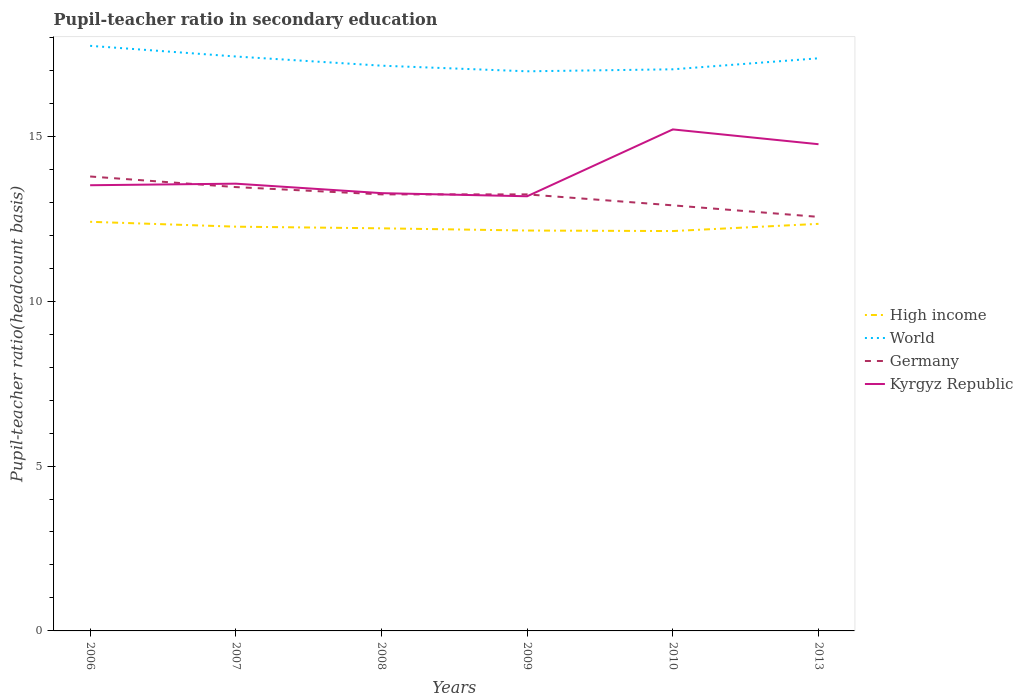Across all years, what is the maximum pupil-teacher ratio in secondary education in High income?
Your response must be concise. 12.13. In which year was the pupil-teacher ratio in secondary education in Germany maximum?
Provide a short and direct response. 2013. What is the total pupil-teacher ratio in secondary education in High income in the graph?
Give a very brief answer. 0.15. What is the difference between the highest and the second highest pupil-teacher ratio in secondary education in High income?
Offer a very short reply. 0.28. How many years are there in the graph?
Provide a succinct answer. 6. What is the difference between two consecutive major ticks on the Y-axis?
Ensure brevity in your answer.  5. Are the values on the major ticks of Y-axis written in scientific E-notation?
Keep it short and to the point. No. Where does the legend appear in the graph?
Provide a short and direct response. Center right. How are the legend labels stacked?
Provide a short and direct response. Vertical. What is the title of the graph?
Your response must be concise. Pupil-teacher ratio in secondary education. Does "Saudi Arabia" appear as one of the legend labels in the graph?
Provide a short and direct response. No. What is the label or title of the Y-axis?
Offer a terse response. Pupil-teacher ratio(headcount basis). What is the Pupil-teacher ratio(headcount basis) in High income in 2006?
Keep it short and to the point. 12.41. What is the Pupil-teacher ratio(headcount basis) of World in 2006?
Provide a succinct answer. 17.74. What is the Pupil-teacher ratio(headcount basis) in Germany in 2006?
Provide a short and direct response. 13.78. What is the Pupil-teacher ratio(headcount basis) of Kyrgyz Republic in 2006?
Provide a succinct answer. 13.52. What is the Pupil-teacher ratio(headcount basis) of High income in 2007?
Your answer should be very brief. 12.26. What is the Pupil-teacher ratio(headcount basis) of World in 2007?
Provide a short and direct response. 17.42. What is the Pupil-teacher ratio(headcount basis) of Germany in 2007?
Give a very brief answer. 13.46. What is the Pupil-teacher ratio(headcount basis) in Kyrgyz Republic in 2007?
Provide a short and direct response. 13.56. What is the Pupil-teacher ratio(headcount basis) in High income in 2008?
Offer a very short reply. 12.21. What is the Pupil-teacher ratio(headcount basis) of World in 2008?
Your response must be concise. 17.14. What is the Pupil-teacher ratio(headcount basis) of Germany in 2008?
Provide a short and direct response. 13.24. What is the Pupil-teacher ratio(headcount basis) in Kyrgyz Republic in 2008?
Keep it short and to the point. 13.28. What is the Pupil-teacher ratio(headcount basis) in High income in 2009?
Offer a terse response. 12.14. What is the Pupil-teacher ratio(headcount basis) in World in 2009?
Keep it short and to the point. 16.97. What is the Pupil-teacher ratio(headcount basis) in Germany in 2009?
Make the answer very short. 13.24. What is the Pupil-teacher ratio(headcount basis) of Kyrgyz Republic in 2009?
Your response must be concise. 13.18. What is the Pupil-teacher ratio(headcount basis) in High income in 2010?
Keep it short and to the point. 12.13. What is the Pupil-teacher ratio(headcount basis) in World in 2010?
Ensure brevity in your answer.  17.03. What is the Pupil-teacher ratio(headcount basis) of Germany in 2010?
Keep it short and to the point. 12.91. What is the Pupil-teacher ratio(headcount basis) in Kyrgyz Republic in 2010?
Offer a terse response. 15.21. What is the Pupil-teacher ratio(headcount basis) in High income in 2013?
Make the answer very short. 12.34. What is the Pupil-teacher ratio(headcount basis) of World in 2013?
Make the answer very short. 17.37. What is the Pupil-teacher ratio(headcount basis) of Germany in 2013?
Give a very brief answer. 12.56. What is the Pupil-teacher ratio(headcount basis) in Kyrgyz Republic in 2013?
Keep it short and to the point. 14.76. Across all years, what is the maximum Pupil-teacher ratio(headcount basis) in High income?
Your answer should be very brief. 12.41. Across all years, what is the maximum Pupil-teacher ratio(headcount basis) in World?
Provide a succinct answer. 17.74. Across all years, what is the maximum Pupil-teacher ratio(headcount basis) of Germany?
Your answer should be very brief. 13.78. Across all years, what is the maximum Pupil-teacher ratio(headcount basis) of Kyrgyz Republic?
Your response must be concise. 15.21. Across all years, what is the minimum Pupil-teacher ratio(headcount basis) in High income?
Give a very brief answer. 12.13. Across all years, what is the minimum Pupil-teacher ratio(headcount basis) in World?
Your answer should be very brief. 16.97. Across all years, what is the minimum Pupil-teacher ratio(headcount basis) in Germany?
Offer a terse response. 12.56. Across all years, what is the minimum Pupil-teacher ratio(headcount basis) of Kyrgyz Republic?
Your response must be concise. 13.18. What is the total Pupil-teacher ratio(headcount basis) in High income in the graph?
Your response must be concise. 73.49. What is the total Pupil-teacher ratio(headcount basis) of World in the graph?
Your answer should be compact. 103.67. What is the total Pupil-teacher ratio(headcount basis) in Germany in the graph?
Your response must be concise. 79.18. What is the total Pupil-teacher ratio(headcount basis) in Kyrgyz Republic in the graph?
Your answer should be compact. 83.51. What is the difference between the Pupil-teacher ratio(headcount basis) in High income in 2006 and that in 2007?
Provide a short and direct response. 0.15. What is the difference between the Pupil-teacher ratio(headcount basis) of World in 2006 and that in 2007?
Your answer should be compact. 0.32. What is the difference between the Pupil-teacher ratio(headcount basis) of Germany in 2006 and that in 2007?
Offer a terse response. 0.32. What is the difference between the Pupil-teacher ratio(headcount basis) in Kyrgyz Republic in 2006 and that in 2007?
Make the answer very short. -0.05. What is the difference between the Pupil-teacher ratio(headcount basis) in High income in 2006 and that in 2008?
Provide a succinct answer. 0.2. What is the difference between the Pupil-teacher ratio(headcount basis) in World in 2006 and that in 2008?
Give a very brief answer. 0.6. What is the difference between the Pupil-teacher ratio(headcount basis) in Germany in 2006 and that in 2008?
Your answer should be compact. 0.54. What is the difference between the Pupil-teacher ratio(headcount basis) of Kyrgyz Republic in 2006 and that in 2008?
Your answer should be very brief. 0.24. What is the difference between the Pupil-teacher ratio(headcount basis) of High income in 2006 and that in 2009?
Give a very brief answer. 0.27. What is the difference between the Pupil-teacher ratio(headcount basis) of World in 2006 and that in 2009?
Keep it short and to the point. 0.77. What is the difference between the Pupil-teacher ratio(headcount basis) in Germany in 2006 and that in 2009?
Offer a very short reply. 0.54. What is the difference between the Pupil-teacher ratio(headcount basis) of Kyrgyz Republic in 2006 and that in 2009?
Offer a very short reply. 0.33. What is the difference between the Pupil-teacher ratio(headcount basis) in High income in 2006 and that in 2010?
Ensure brevity in your answer.  0.28. What is the difference between the Pupil-teacher ratio(headcount basis) in World in 2006 and that in 2010?
Provide a succinct answer. 0.71. What is the difference between the Pupil-teacher ratio(headcount basis) of Germany in 2006 and that in 2010?
Offer a very short reply. 0.88. What is the difference between the Pupil-teacher ratio(headcount basis) in Kyrgyz Republic in 2006 and that in 2010?
Offer a terse response. -1.69. What is the difference between the Pupil-teacher ratio(headcount basis) in High income in 2006 and that in 2013?
Ensure brevity in your answer.  0.06. What is the difference between the Pupil-teacher ratio(headcount basis) in World in 2006 and that in 2013?
Provide a short and direct response. 0.38. What is the difference between the Pupil-teacher ratio(headcount basis) of Germany in 2006 and that in 2013?
Offer a terse response. 1.22. What is the difference between the Pupil-teacher ratio(headcount basis) in Kyrgyz Republic in 2006 and that in 2013?
Your answer should be compact. -1.24. What is the difference between the Pupil-teacher ratio(headcount basis) in High income in 2007 and that in 2008?
Provide a succinct answer. 0.05. What is the difference between the Pupil-teacher ratio(headcount basis) in World in 2007 and that in 2008?
Offer a terse response. 0.28. What is the difference between the Pupil-teacher ratio(headcount basis) in Germany in 2007 and that in 2008?
Provide a short and direct response. 0.22. What is the difference between the Pupil-teacher ratio(headcount basis) of Kyrgyz Republic in 2007 and that in 2008?
Provide a short and direct response. 0.29. What is the difference between the Pupil-teacher ratio(headcount basis) of High income in 2007 and that in 2009?
Keep it short and to the point. 0.12. What is the difference between the Pupil-teacher ratio(headcount basis) in World in 2007 and that in 2009?
Ensure brevity in your answer.  0.45. What is the difference between the Pupil-teacher ratio(headcount basis) in Germany in 2007 and that in 2009?
Provide a succinct answer. 0.22. What is the difference between the Pupil-teacher ratio(headcount basis) in Kyrgyz Republic in 2007 and that in 2009?
Provide a succinct answer. 0.38. What is the difference between the Pupil-teacher ratio(headcount basis) in High income in 2007 and that in 2010?
Your answer should be very brief. 0.13. What is the difference between the Pupil-teacher ratio(headcount basis) in World in 2007 and that in 2010?
Offer a terse response. 0.39. What is the difference between the Pupil-teacher ratio(headcount basis) in Germany in 2007 and that in 2010?
Your answer should be compact. 0.55. What is the difference between the Pupil-teacher ratio(headcount basis) of Kyrgyz Republic in 2007 and that in 2010?
Provide a short and direct response. -1.65. What is the difference between the Pupil-teacher ratio(headcount basis) in High income in 2007 and that in 2013?
Keep it short and to the point. -0.09. What is the difference between the Pupil-teacher ratio(headcount basis) in World in 2007 and that in 2013?
Ensure brevity in your answer.  0.05. What is the difference between the Pupil-teacher ratio(headcount basis) of Germany in 2007 and that in 2013?
Make the answer very short. 0.9. What is the difference between the Pupil-teacher ratio(headcount basis) in Kyrgyz Republic in 2007 and that in 2013?
Ensure brevity in your answer.  -1.2. What is the difference between the Pupil-teacher ratio(headcount basis) of High income in 2008 and that in 2009?
Keep it short and to the point. 0.07. What is the difference between the Pupil-teacher ratio(headcount basis) of World in 2008 and that in 2009?
Your response must be concise. 0.17. What is the difference between the Pupil-teacher ratio(headcount basis) in Kyrgyz Republic in 2008 and that in 2009?
Offer a very short reply. 0.1. What is the difference between the Pupil-teacher ratio(headcount basis) of High income in 2008 and that in 2010?
Make the answer very short. 0.08. What is the difference between the Pupil-teacher ratio(headcount basis) in World in 2008 and that in 2010?
Your answer should be very brief. 0.11. What is the difference between the Pupil-teacher ratio(headcount basis) in Germany in 2008 and that in 2010?
Offer a terse response. 0.33. What is the difference between the Pupil-teacher ratio(headcount basis) in Kyrgyz Republic in 2008 and that in 2010?
Offer a terse response. -1.93. What is the difference between the Pupil-teacher ratio(headcount basis) of High income in 2008 and that in 2013?
Provide a short and direct response. -0.14. What is the difference between the Pupil-teacher ratio(headcount basis) of World in 2008 and that in 2013?
Your response must be concise. -0.22. What is the difference between the Pupil-teacher ratio(headcount basis) in Germany in 2008 and that in 2013?
Offer a terse response. 0.68. What is the difference between the Pupil-teacher ratio(headcount basis) of Kyrgyz Republic in 2008 and that in 2013?
Your response must be concise. -1.48. What is the difference between the Pupil-teacher ratio(headcount basis) of High income in 2009 and that in 2010?
Provide a succinct answer. 0.02. What is the difference between the Pupil-teacher ratio(headcount basis) in World in 2009 and that in 2010?
Give a very brief answer. -0.06. What is the difference between the Pupil-teacher ratio(headcount basis) in Germany in 2009 and that in 2010?
Offer a very short reply. 0.33. What is the difference between the Pupil-teacher ratio(headcount basis) in Kyrgyz Republic in 2009 and that in 2010?
Ensure brevity in your answer.  -2.03. What is the difference between the Pupil-teacher ratio(headcount basis) of High income in 2009 and that in 2013?
Give a very brief answer. -0.2. What is the difference between the Pupil-teacher ratio(headcount basis) of World in 2009 and that in 2013?
Keep it short and to the point. -0.39. What is the difference between the Pupil-teacher ratio(headcount basis) of Germany in 2009 and that in 2013?
Your answer should be very brief. 0.68. What is the difference between the Pupil-teacher ratio(headcount basis) of Kyrgyz Republic in 2009 and that in 2013?
Offer a terse response. -1.58. What is the difference between the Pupil-teacher ratio(headcount basis) of High income in 2010 and that in 2013?
Provide a short and direct response. -0.22. What is the difference between the Pupil-teacher ratio(headcount basis) of World in 2010 and that in 2013?
Ensure brevity in your answer.  -0.33. What is the difference between the Pupil-teacher ratio(headcount basis) in Germany in 2010 and that in 2013?
Your response must be concise. 0.35. What is the difference between the Pupil-teacher ratio(headcount basis) of Kyrgyz Republic in 2010 and that in 2013?
Ensure brevity in your answer.  0.45. What is the difference between the Pupil-teacher ratio(headcount basis) of High income in 2006 and the Pupil-teacher ratio(headcount basis) of World in 2007?
Make the answer very short. -5.01. What is the difference between the Pupil-teacher ratio(headcount basis) of High income in 2006 and the Pupil-teacher ratio(headcount basis) of Germany in 2007?
Ensure brevity in your answer.  -1.05. What is the difference between the Pupil-teacher ratio(headcount basis) of High income in 2006 and the Pupil-teacher ratio(headcount basis) of Kyrgyz Republic in 2007?
Keep it short and to the point. -1.16. What is the difference between the Pupil-teacher ratio(headcount basis) in World in 2006 and the Pupil-teacher ratio(headcount basis) in Germany in 2007?
Ensure brevity in your answer.  4.28. What is the difference between the Pupil-teacher ratio(headcount basis) of World in 2006 and the Pupil-teacher ratio(headcount basis) of Kyrgyz Republic in 2007?
Your answer should be compact. 4.18. What is the difference between the Pupil-teacher ratio(headcount basis) of Germany in 2006 and the Pupil-teacher ratio(headcount basis) of Kyrgyz Republic in 2007?
Give a very brief answer. 0.22. What is the difference between the Pupil-teacher ratio(headcount basis) in High income in 2006 and the Pupil-teacher ratio(headcount basis) in World in 2008?
Offer a very short reply. -4.73. What is the difference between the Pupil-teacher ratio(headcount basis) of High income in 2006 and the Pupil-teacher ratio(headcount basis) of Germany in 2008?
Your answer should be very brief. -0.83. What is the difference between the Pupil-teacher ratio(headcount basis) of High income in 2006 and the Pupil-teacher ratio(headcount basis) of Kyrgyz Republic in 2008?
Provide a succinct answer. -0.87. What is the difference between the Pupil-teacher ratio(headcount basis) of World in 2006 and the Pupil-teacher ratio(headcount basis) of Germany in 2008?
Make the answer very short. 4.5. What is the difference between the Pupil-teacher ratio(headcount basis) of World in 2006 and the Pupil-teacher ratio(headcount basis) of Kyrgyz Republic in 2008?
Your answer should be very brief. 4.47. What is the difference between the Pupil-teacher ratio(headcount basis) in Germany in 2006 and the Pupil-teacher ratio(headcount basis) in Kyrgyz Republic in 2008?
Your response must be concise. 0.5. What is the difference between the Pupil-teacher ratio(headcount basis) of High income in 2006 and the Pupil-teacher ratio(headcount basis) of World in 2009?
Keep it short and to the point. -4.56. What is the difference between the Pupil-teacher ratio(headcount basis) of High income in 2006 and the Pupil-teacher ratio(headcount basis) of Germany in 2009?
Provide a succinct answer. -0.83. What is the difference between the Pupil-teacher ratio(headcount basis) of High income in 2006 and the Pupil-teacher ratio(headcount basis) of Kyrgyz Republic in 2009?
Offer a terse response. -0.77. What is the difference between the Pupil-teacher ratio(headcount basis) of World in 2006 and the Pupil-teacher ratio(headcount basis) of Germany in 2009?
Offer a terse response. 4.5. What is the difference between the Pupil-teacher ratio(headcount basis) in World in 2006 and the Pupil-teacher ratio(headcount basis) in Kyrgyz Republic in 2009?
Provide a succinct answer. 4.56. What is the difference between the Pupil-teacher ratio(headcount basis) of Germany in 2006 and the Pupil-teacher ratio(headcount basis) of Kyrgyz Republic in 2009?
Make the answer very short. 0.6. What is the difference between the Pupil-teacher ratio(headcount basis) of High income in 2006 and the Pupil-teacher ratio(headcount basis) of World in 2010?
Provide a short and direct response. -4.62. What is the difference between the Pupil-teacher ratio(headcount basis) of High income in 2006 and the Pupil-teacher ratio(headcount basis) of Germany in 2010?
Offer a terse response. -0.5. What is the difference between the Pupil-teacher ratio(headcount basis) of High income in 2006 and the Pupil-teacher ratio(headcount basis) of Kyrgyz Republic in 2010?
Make the answer very short. -2.8. What is the difference between the Pupil-teacher ratio(headcount basis) of World in 2006 and the Pupil-teacher ratio(headcount basis) of Germany in 2010?
Offer a very short reply. 4.84. What is the difference between the Pupil-teacher ratio(headcount basis) in World in 2006 and the Pupil-teacher ratio(headcount basis) in Kyrgyz Republic in 2010?
Ensure brevity in your answer.  2.53. What is the difference between the Pupil-teacher ratio(headcount basis) of Germany in 2006 and the Pupil-teacher ratio(headcount basis) of Kyrgyz Republic in 2010?
Provide a succinct answer. -1.43. What is the difference between the Pupil-teacher ratio(headcount basis) of High income in 2006 and the Pupil-teacher ratio(headcount basis) of World in 2013?
Make the answer very short. -4.96. What is the difference between the Pupil-teacher ratio(headcount basis) of High income in 2006 and the Pupil-teacher ratio(headcount basis) of Germany in 2013?
Offer a very short reply. -0.15. What is the difference between the Pupil-teacher ratio(headcount basis) in High income in 2006 and the Pupil-teacher ratio(headcount basis) in Kyrgyz Republic in 2013?
Give a very brief answer. -2.35. What is the difference between the Pupil-teacher ratio(headcount basis) in World in 2006 and the Pupil-teacher ratio(headcount basis) in Germany in 2013?
Provide a succinct answer. 5.19. What is the difference between the Pupil-teacher ratio(headcount basis) in World in 2006 and the Pupil-teacher ratio(headcount basis) in Kyrgyz Republic in 2013?
Provide a succinct answer. 2.98. What is the difference between the Pupil-teacher ratio(headcount basis) in Germany in 2006 and the Pupil-teacher ratio(headcount basis) in Kyrgyz Republic in 2013?
Give a very brief answer. -0.98. What is the difference between the Pupil-teacher ratio(headcount basis) in High income in 2007 and the Pupil-teacher ratio(headcount basis) in World in 2008?
Ensure brevity in your answer.  -4.88. What is the difference between the Pupil-teacher ratio(headcount basis) in High income in 2007 and the Pupil-teacher ratio(headcount basis) in Germany in 2008?
Keep it short and to the point. -0.98. What is the difference between the Pupil-teacher ratio(headcount basis) in High income in 2007 and the Pupil-teacher ratio(headcount basis) in Kyrgyz Republic in 2008?
Offer a terse response. -1.02. What is the difference between the Pupil-teacher ratio(headcount basis) of World in 2007 and the Pupil-teacher ratio(headcount basis) of Germany in 2008?
Provide a succinct answer. 4.18. What is the difference between the Pupil-teacher ratio(headcount basis) of World in 2007 and the Pupil-teacher ratio(headcount basis) of Kyrgyz Republic in 2008?
Keep it short and to the point. 4.14. What is the difference between the Pupil-teacher ratio(headcount basis) of Germany in 2007 and the Pupil-teacher ratio(headcount basis) of Kyrgyz Republic in 2008?
Keep it short and to the point. 0.18. What is the difference between the Pupil-teacher ratio(headcount basis) in High income in 2007 and the Pupil-teacher ratio(headcount basis) in World in 2009?
Provide a short and direct response. -4.71. What is the difference between the Pupil-teacher ratio(headcount basis) in High income in 2007 and the Pupil-teacher ratio(headcount basis) in Germany in 2009?
Provide a short and direct response. -0.98. What is the difference between the Pupil-teacher ratio(headcount basis) in High income in 2007 and the Pupil-teacher ratio(headcount basis) in Kyrgyz Republic in 2009?
Ensure brevity in your answer.  -0.92. What is the difference between the Pupil-teacher ratio(headcount basis) in World in 2007 and the Pupil-teacher ratio(headcount basis) in Germany in 2009?
Make the answer very short. 4.18. What is the difference between the Pupil-teacher ratio(headcount basis) of World in 2007 and the Pupil-teacher ratio(headcount basis) of Kyrgyz Republic in 2009?
Keep it short and to the point. 4.24. What is the difference between the Pupil-teacher ratio(headcount basis) in Germany in 2007 and the Pupil-teacher ratio(headcount basis) in Kyrgyz Republic in 2009?
Offer a terse response. 0.28. What is the difference between the Pupil-teacher ratio(headcount basis) in High income in 2007 and the Pupil-teacher ratio(headcount basis) in World in 2010?
Your response must be concise. -4.77. What is the difference between the Pupil-teacher ratio(headcount basis) in High income in 2007 and the Pupil-teacher ratio(headcount basis) in Germany in 2010?
Give a very brief answer. -0.65. What is the difference between the Pupil-teacher ratio(headcount basis) in High income in 2007 and the Pupil-teacher ratio(headcount basis) in Kyrgyz Republic in 2010?
Offer a very short reply. -2.95. What is the difference between the Pupil-teacher ratio(headcount basis) in World in 2007 and the Pupil-teacher ratio(headcount basis) in Germany in 2010?
Make the answer very short. 4.51. What is the difference between the Pupil-teacher ratio(headcount basis) in World in 2007 and the Pupil-teacher ratio(headcount basis) in Kyrgyz Republic in 2010?
Provide a short and direct response. 2.21. What is the difference between the Pupil-teacher ratio(headcount basis) in Germany in 2007 and the Pupil-teacher ratio(headcount basis) in Kyrgyz Republic in 2010?
Keep it short and to the point. -1.75. What is the difference between the Pupil-teacher ratio(headcount basis) of High income in 2007 and the Pupil-teacher ratio(headcount basis) of World in 2013?
Provide a short and direct response. -5.11. What is the difference between the Pupil-teacher ratio(headcount basis) in High income in 2007 and the Pupil-teacher ratio(headcount basis) in Germany in 2013?
Make the answer very short. -0.3. What is the difference between the Pupil-teacher ratio(headcount basis) in High income in 2007 and the Pupil-teacher ratio(headcount basis) in Kyrgyz Republic in 2013?
Ensure brevity in your answer.  -2.5. What is the difference between the Pupil-teacher ratio(headcount basis) in World in 2007 and the Pupil-teacher ratio(headcount basis) in Germany in 2013?
Give a very brief answer. 4.86. What is the difference between the Pupil-teacher ratio(headcount basis) of World in 2007 and the Pupil-teacher ratio(headcount basis) of Kyrgyz Republic in 2013?
Offer a very short reply. 2.66. What is the difference between the Pupil-teacher ratio(headcount basis) of Germany in 2007 and the Pupil-teacher ratio(headcount basis) of Kyrgyz Republic in 2013?
Your answer should be compact. -1.3. What is the difference between the Pupil-teacher ratio(headcount basis) of High income in 2008 and the Pupil-teacher ratio(headcount basis) of World in 2009?
Offer a very short reply. -4.76. What is the difference between the Pupil-teacher ratio(headcount basis) in High income in 2008 and the Pupil-teacher ratio(headcount basis) in Germany in 2009?
Ensure brevity in your answer.  -1.03. What is the difference between the Pupil-teacher ratio(headcount basis) of High income in 2008 and the Pupil-teacher ratio(headcount basis) of Kyrgyz Republic in 2009?
Your answer should be very brief. -0.97. What is the difference between the Pupil-teacher ratio(headcount basis) in World in 2008 and the Pupil-teacher ratio(headcount basis) in Germany in 2009?
Ensure brevity in your answer.  3.9. What is the difference between the Pupil-teacher ratio(headcount basis) in World in 2008 and the Pupil-teacher ratio(headcount basis) in Kyrgyz Republic in 2009?
Offer a terse response. 3.96. What is the difference between the Pupil-teacher ratio(headcount basis) of Germany in 2008 and the Pupil-teacher ratio(headcount basis) of Kyrgyz Republic in 2009?
Keep it short and to the point. 0.06. What is the difference between the Pupil-teacher ratio(headcount basis) of High income in 2008 and the Pupil-teacher ratio(headcount basis) of World in 2010?
Offer a terse response. -4.82. What is the difference between the Pupil-teacher ratio(headcount basis) in High income in 2008 and the Pupil-teacher ratio(headcount basis) in Germany in 2010?
Give a very brief answer. -0.7. What is the difference between the Pupil-teacher ratio(headcount basis) of High income in 2008 and the Pupil-teacher ratio(headcount basis) of Kyrgyz Republic in 2010?
Offer a very short reply. -3. What is the difference between the Pupil-teacher ratio(headcount basis) in World in 2008 and the Pupil-teacher ratio(headcount basis) in Germany in 2010?
Give a very brief answer. 4.24. What is the difference between the Pupil-teacher ratio(headcount basis) of World in 2008 and the Pupil-teacher ratio(headcount basis) of Kyrgyz Republic in 2010?
Provide a short and direct response. 1.93. What is the difference between the Pupil-teacher ratio(headcount basis) in Germany in 2008 and the Pupil-teacher ratio(headcount basis) in Kyrgyz Republic in 2010?
Provide a succinct answer. -1.97. What is the difference between the Pupil-teacher ratio(headcount basis) of High income in 2008 and the Pupil-teacher ratio(headcount basis) of World in 2013?
Ensure brevity in your answer.  -5.16. What is the difference between the Pupil-teacher ratio(headcount basis) of High income in 2008 and the Pupil-teacher ratio(headcount basis) of Germany in 2013?
Make the answer very short. -0.35. What is the difference between the Pupil-teacher ratio(headcount basis) in High income in 2008 and the Pupil-teacher ratio(headcount basis) in Kyrgyz Republic in 2013?
Keep it short and to the point. -2.55. What is the difference between the Pupil-teacher ratio(headcount basis) in World in 2008 and the Pupil-teacher ratio(headcount basis) in Germany in 2013?
Give a very brief answer. 4.59. What is the difference between the Pupil-teacher ratio(headcount basis) of World in 2008 and the Pupil-teacher ratio(headcount basis) of Kyrgyz Republic in 2013?
Your answer should be very brief. 2.38. What is the difference between the Pupil-teacher ratio(headcount basis) in Germany in 2008 and the Pupil-teacher ratio(headcount basis) in Kyrgyz Republic in 2013?
Provide a succinct answer. -1.52. What is the difference between the Pupil-teacher ratio(headcount basis) of High income in 2009 and the Pupil-teacher ratio(headcount basis) of World in 2010?
Give a very brief answer. -4.89. What is the difference between the Pupil-teacher ratio(headcount basis) of High income in 2009 and the Pupil-teacher ratio(headcount basis) of Germany in 2010?
Make the answer very short. -0.76. What is the difference between the Pupil-teacher ratio(headcount basis) of High income in 2009 and the Pupil-teacher ratio(headcount basis) of Kyrgyz Republic in 2010?
Your answer should be very brief. -3.07. What is the difference between the Pupil-teacher ratio(headcount basis) of World in 2009 and the Pupil-teacher ratio(headcount basis) of Germany in 2010?
Your answer should be compact. 4.07. What is the difference between the Pupil-teacher ratio(headcount basis) in World in 2009 and the Pupil-teacher ratio(headcount basis) in Kyrgyz Republic in 2010?
Ensure brevity in your answer.  1.76. What is the difference between the Pupil-teacher ratio(headcount basis) of Germany in 2009 and the Pupil-teacher ratio(headcount basis) of Kyrgyz Republic in 2010?
Your response must be concise. -1.97. What is the difference between the Pupil-teacher ratio(headcount basis) of High income in 2009 and the Pupil-teacher ratio(headcount basis) of World in 2013?
Make the answer very short. -5.22. What is the difference between the Pupil-teacher ratio(headcount basis) in High income in 2009 and the Pupil-teacher ratio(headcount basis) in Germany in 2013?
Offer a very short reply. -0.41. What is the difference between the Pupil-teacher ratio(headcount basis) in High income in 2009 and the Pupil-teacher ratio(headcount basis) in Kyrgyz Republic in 2013?
Provide a short and direct response. -2.62. What is the difference between the Pupil-teacher ratio(headcount basis) in World in 2009 and the Pupil-teacher ratio(headcount basis) in Germany in 2013?
Provide a succinct answer. 4.41. What is the difference between the Pupil-teacher ratio(headcount basis) of World in 2009 and the Pupil-teacher ratio(headcount basis) of Kyrgyz Republic in 2013?
Your answer should be very brief. 2.21. What is the difference between the Pupil-teacher ratio(headcount basis) in Germany in 2009 and the Pupil-teacher ratio(headcount basis) in Kyrgyz Republic in 2013?
Keep it short and to the point. -1.52. What is the difference between the Pupil-teacher ratio(headcount basis) in High income in 2010 and the Pupil-teacher ratio(headcount basis) in World in 2013?
Your answer should be compact. -5.24. What is the difference between the Pupil-teacher ratio(headcount basis) in High income in 2010 and the Pupil-teacher ratio(headcount basis) in Germany in 2013?
Offer a very short reply. -0.43. What is the difference between the Pupil-teacher ratio(headcount basis) of High income in 2010 and the Pupil-teacher ratio(headcount basis) of Kyrgyz Republic in 2013?
Provide a succinct answer. -2.63. What is the difference between the Pupil-teacher ratio(headcount basis) in World in 2010 and the Pupil-teacher ratio(headcount basis) in Germany in 2013?
Offer a very short reply. 4.48. What is the difference between the Pupil-teacher ratio(headcount basis) of World in 2010 and the Pupil-teacher ratio(headcount basis) of Kyrgyz Republic in 2013?
Provide a succinct answer. 2.27. What is the difference between the Pupil-teacher ratio(headcount basis) in Germany in 2010 and the Pupil-teacher ratio(headcount basis) in Kyrgyz Republic in 2013?
Your response must be concise. -1.85. What is the average Pupil-teacher ratio(headcount basis) of High income per year?
Offer a terse response. 12.25. What is the average Pupil-teacher ratio(headcount basis) in World per year?
Provide a succinct answer. 17.28. What is the average Pupil-teacher ratio(headcount basis) of Germany per year?
Offer a terse response. 13.2. What is the average Pupil-teacher ratio(headcount basis) in Kyrgyz Republic per year?
Make the answer very short. 13.92. In the year 2006, what is the difference between the Pupil-teacher ratio(headcount basis) in High income and Pupil-teacher ratio(headcount basis) in World?
Offer a terse response. -5.34. In the year 2006, what is the difference between the Pupil-teacher ratio(headcount basis) of High income and Pupil-teacher ratio(headcount basis) of Germany?
Ensure brevity in your answer.  -1.37. In the year 2006, what is the difference between the Pupil-teacher ratio(headcount basis) of High income and Pupil-teacher ratio(headcount basis) of Kyrgyz Republic?
Your response must be concise. -1.11. In the year 2006, what is the difference between the Pupil-teacher ratio(headcount basis) of World and Pupil-teacher ratio(headcount basis) of Germany?
Ensure brevity in your answer.  3.96. In the year 2006, what is the difference between the Pupil-teacher ratio(headcount basis) of World and Pupil-teacher ratio(headcount basis) of Kyrgyz Republic?
Provide a succinct answer. 4.23. In the year 2006, what is the difference between the Pupil-teacher ratio(headcount basis) in Germany and Pupil-teacher ratio(headcount basis) in Kyrgyz Republic?
Offer a very short reply. 0.27. In the year 2007, what is the difference between the Pupil-teacher ratio(headcount basis) of High income and Pupil-teacher ratio(headcount basis) of World?
Offer a very short reply. -5.16. In the year 2007, what is the difference between the Pupil-teacher ratio(headcount basis) in High income and Pupil-teacher ratio(headcount basis) in Germany?
Your answer should be compact. -1.2. In the year 2007, what is the difference between the Pupil-teacher ratio(headcount basis) of High income and Pupil-teacher ratio(headcount basis) of Kyrgyz Republic?
Keep it short and to the point. -1.3. In the year 2007, what is the difference between the Pupil-teacher ratio(headcount basis) of World and Pupil-teacher ratio(headcount basis) of Germany?
Make the answer very short. 3.96. In the year 2007, what is the difference between the Pupil-teacher ratio(headcount basis) of World and Pupil-teacher ratio(headcount basis) of Kyrgyz Republic?
Provide a short and direct response. 3.86. In the year 2007, what is the difference between the Pupil-teacher ratio(headcount basis) in Germany and Pupil-teacher ratio(headcount basis) in Kyrgyz Republic?
Keep it short and to the point. -0.1. In the year 2008, what is the difference between the Pupil-teacher ratio(headcount basis) in High income and Pupil-teacher ratio(headcount basis) in World?
Ensure brevity in your answer.  -4.93. In the year 2008, what is the difference between the Pupil-teacher ratio(headcount basis) of High income and Pupil-teacher ratio(headcount basis) of Germany?
Keep it short and to the point. -1.03. In the year 2008, what is the difference between the Pupil-teacher ratio(headcount basis) of High income and Pupil-teacher ratio(headcount basis) of Kyrgyz Republic?
Your answer should be very brief. -1.07. In the year 2008, what is the difference between the Pupil-teacher ratio(headcount basis) of World and Pupil-teacher ratio(headcount basis) of Germany?
Keep it short and to the point. 3.9. In the year 2008, what is the difference between the Pupil-teacher ratio(headcount basis) of World and Pupil-teacher ratio(headcount basis) of Kyrgyz Republic?
Give a very brief answer. 3.87. In the year 2008, what is the difference between the Pupil-teacher ratio(headcount basis) in Germany and Pupil-teacher ratio(headcount basis) in Kyrgyz Republic?
Make the answer very short. -0.04. In the year 2009, what is the difference between the Pupil-teacher ratio(headcount basis) of High income and Pupil-teacher ratio(headcount basis) of World?
Your answer should be very brief. -4.83. In the year 2009, what is the difference between the Pupil-teacher ratio(headcount basis) of High income and Pupil-teacher ratio(headcount basis) of Germany?
Provide a succinct answer. -1.1. In the year 2009, what is the difference between the Pupil-teacher ratio(headcount basis) of High income and Pupil-teacher ratio(headcount basis) of Kyrgyz Republic?
Offer a terse response. -1.04. In the year 2009, what is the difference between the Pupil-teacher ratio(headcount basis) of World and Pupil-teacher ratio(headcount basis) of Germany?
Provide a short and direct response. 3.73. In the year 2009, what is the difference between the Pupil-teacher ratio(headcount basis) of World and Pupil-teacher ratio(headcount basis) of Kyrgyz Republic?
Make the answer very short. 3.79. In the year 2009, what is the difference between the Pupil-teacher ratio(headcount basis) in Germany and Pupil-teacher ratio(headcount basis) in Kyrgyz Republic?
Your answer should be very brief. 0.06. In the year 2010, what is the difference between the Pupil-teacher ratio(headcount basis) in High income and Pupil-teacher ratio(headcount basis) in World?
Provide a succinct answer. -4.91. In the year 2010, what is the difference between the Pupil-teacher ratio(headcount basis) in High income and Pupil-teacher ratio(headcount basis) in Germany?
Ensure brevity in your answer.  -0.78. In the year 2010, what is the difference between the Pupil-teacher ratio(headcount basis) of High income and Pupil-teacher ratio(headcount basis) of Kyrgyz Republic?
Ensure brevity in your answer.  -3.08. In the year 2010, what is the difference between the Pupil-teacher ratio(headcount basis) of World and Pupil-teacher ratio(headcount basis) of Germany?
Give a very brief answer. 4.13. In the year 2010, what is the difference between the Pupil-teacher ratio(headcount basis) of World and Pupil-teacher ratio(headcount basis) of Kyrgyz Republic?
Provide a succinct answer. 1.82. In the year 2010, what is the difference between the Pupil-teacher ratio(headcount basis) in Germany and Pupil-teacher ratio(headcount basis) in Kyrgyz Republic?
Keep it short and to the point. -2.3. In the year 2013, what is the difference between the Pupil-teacher ratio(headcount basis) of High income and Pupil-teacher ratio(headcount basis) of World?
Your response must be concise. -5.02. In the year 2013, what is the difference between the Pupil-teacher ratio(headcount basis) of High income and Pupil-teacher ratio(headcount basis) of Germany?
Provide a short and direct response. -0.21. In the year 2013, what is the difference between the Pupil-teacher ratio(headcount basis) in High income and Pupil-teacher ratio(headcount basis) in Kyrgyz Republic?
Give a very brief answer. -2.42. In the year 2013, what is the difference between the Pupil-teacher ratio(headcount basis) of World and Pupil-teacher ratio(headcount basis) of Germany?
Your response must be concise. 4.81. In the year 2013, what is the difference between the Pupil-teacher ratio(headcount basis) in World and Pupil-teacher ratio(headcount basis) in Kyrgyz Republic?
Provide a short and direct response. 2.61. In the year 2013, what is the difference between the Pupil-teacher ratio(headcount basis) of Germany and Pupil-teacher ratio(headcount basis) of Kyrgyz Republic?
Provide a succinct answer. -2.2. What is the ratio of the Pupil-teacher ratio(headcount basis) in High income in 2006 to that in 2007?
Make the answer very short. 1.01. What is the ratio of the Pupil-teacher ratio(headcount basis) of World in 2006 to that in 2007?
Your answer should be compact. 1.02. What is the ratio of the Pupil-teacher ratio(headcount basis) of Germany in 2006 to that in 2007?
Your response must be concise. 1.02. What is the ratio of the Pupil-teacher ratio(headcount basis) in Kyrgyz Republic in 2006 to that in 2007?
Your answer should be very brief. 1. What is the ratio of the Pupil-teacher ratio(headcount basis) in High income in 2006 to that in 2008?
Ensure brevity in your answer.  1.02. What is the ratio of the Pupil-teacher ratio(headcount basis) in World in 2006 to that in 2008?
Keep it short and to the point. 1.04. What is the ratio of the Pupil-teacher ratio(headcount basis) of Germany in 2006 to that in 2008?
Offer a very short reply. 1.04. What is the ratio of the Pupil-teacher ratio(headcount basis) of Kyrgyz Republic in 2006 to that in 2008?
Provide a short and direct response. 1.02. What is the ratio of the Pupil-teacher ratio(headcount basis) in High income in 2006 to that in 2009?
Your response must be concise. 1.02. What is the ratio of the Pupil-teacher ratio(headcount basis) in World in 2006 to that in 2009?
Keep it short and to the point. 1.05. What is the ratio of the Pupil-teacher ratio(headcount basis) in Germany in 2006 to that in 2009?
Provide a succinct answer. 1.04. What is the ratio of the Pupil-teacher ratio(headcount basis) of Kyrgyz Republic in 2006 to that in 2009?
Provide a succinct answer. 1.03. What is the ratio of the Pupil-teacher ratio(headcount basis) in High income in 2006 to that in 2010?
Your response must be concise. 1.02. What is the ratio of the Pupil-teacher ratio(headcount basis) in World in 2006 to that in 2010?
Offer a very short reply. 1.04. What is the ratio of the Pupil-teacher ratio(headcount basis) in Germany in 2006 to that in 2010?
Make the answer very short. 1.07. What is the ratio of the Pupil-teacher ratio(headcount basis) in Kyrgyz Republic in 2006 to that in 2010?
Provide a succinct answer. 0.89. What is the ratio of the Pupil-teacher ratio(headcount basis) in World in 2006 to that in 2013?
Your response must be concise. 1.02. What is the ratio of the Pupil-teacher ratio(headcount basis) in Germany in 2006 to that in 2013?
Make the answer very short. 1.1. What is the ratio of the Pupil-teacher ratio(headcount basis) of Kyrgyz Republic in 2006 to that in 2013?
Provide a succinct answer. 0.92. What is the ratio of the Pupil-teacher ratio(headcount basis) of World in 2007 to that in 2008?
Ensure brevity in your answer.  1.02. What is the ratio of the Pupil-teacher ratio(headcount basis) in Germany in 2007 to that in 2008?
Your response must be concise. 1.02. What is the ratio of the Pupil-teacher ratio(headcount basis) of Kyrgyz Republic in 2007 to that in 2008?
Provide a short and direct response. 1.02. What is the ratio of the Pupil-teacher ratio(headcount basis) in High income in 2007 to that in 2009?
Ensure brevity in your answer.  1.01. What is the ratio of the Pupil-teacher ratio(headcount basis) of World in 2007 to that in 2009?
Provide a succinct answer. 1.03. What is the ratio of the Pupil-teacher ratio(headcount basis) of Germany in 2007 to that in 2009?
Give a very brief answer. 1.02. What is the ratio of the Pupil-teacher ratio(headcount basis) of High income in 2007 to that in 2010?
Your answer should be compact. 1.01. What is the ratio of the Pupil-teacher ratio(headcount basis) of World in 2007 to that in 2010?
Provide a succinct answer. 1.02. What is the ratio of the Pupil-teacher ratio(headcount basis) in Germany in 2007 to that in 2010?
Provide a short and direct response. 1.04. What is the ratio of the Pupil-teacher ratio(headcount basis) in Kyrgyz Republic in 2007 to that in 2010?
Give a very brief answer. 0.89. What is the ratio of the Pupil-teacher ratio(headcount basis) in High income in 2007 to that in 2013?
Make the answer very short. 0.99. What is the ratio of the Pupil-teacher ratio(headcount basis) in World in 2007 to that in 2013?
Your answer should be very brief. 1. What is the ratio of the Pupil-teacher ratio(headcount basis) in Germany in 2007 to that in 2013?
Keep it short and to the point. 1.07. What is the ratio of the Pupil-teacher ratio(headcount basis) of Kyrgyz Republic in 2007 to that in 2013?
Ensure brevity in your answer.  0.92. What is the ratio of the Pupil-teacher ratio(headcount basis) in High income in 2008 to that in 2009?
Ensure brevity in your answer.  1.01. What is the ratio of the Pupil-teacher ratio(headcount basis) in World in 2008 to that in 2009?
Provide a short and direct response. 1.01. What is the ratio of the Pupil-teacher ratio(headcount basis) in Germany in 2008 to that in 2009?
Provide a succinct answer. 1. What is the ratio of the Pupil-teacher ratio(headcount basis) in High income in 2008 to that in 2010?
Your answer should be very brief. 1.01. What is the ratio of the Pupil-teacher ratio(headcount basis) of World in 2008 to that in 2010?
Keep it short and to the point. 1.01. What is the ratio of the Pupil-teacher ratio(headcount basis) of Germany in 2008 to that in 2010?
Your answer should be compact. 1.03. What is the ratio of the Pupil-teacher ratio(headcount basis) of Kyrgyz Republic in 2008 to that in 2010?
Your answer should be very brief. 0.87. What is the ratio of the Pupil-teacher ratio(headcount basis) of World in 2008 to that in 2013?
Provide a short and direct response. 0.99. What is the ratio of the Pupil-teacher ratio(headcount basis) of Germany in 2008 to that in 2013?
Give a very brief answer. 1.05. What is the ratio of the Pupil-teacher ratio(headcount basis) in Kyrgyz Republic in 2008 to that in 2013?
Your answer should be compact. 0.9. What is the ratio of the Pupil-teacher ratio(headcount basis) in Germany in 2009 to that in 2010?
Offer a very short reply. 1.03. What is the ratio of the Pupil-teacher ratio(headcount basis) in Kyrgyz Republic in 2009 to that in 2010?
Keep it short and to the point. 0.87. What is the ratio of the Pupil-teacher ratio(headcount basis) of High income in 2009 to that in 2013?
Provide a succinct answer. 0.98. What is the ratio of the Pupil-teacher ratio(headcount basis) in World in 2009 to that in 2013?
Give a very brief answer. 0.98. What is the ratio of the Pupil-teacher ratio(headcount basis) of Germany in 2009 to that in 2013?
Provide a short and direct response. 1.05. What is the ratio of the Pupil-teacher ratio(headcount basis) of Kyrgyz Republic in 2009 to that in 2013?
Your answer should be compact. 0.89. What is the ratio of the Pupil-teacher ratio(headcount basis) in High income in 2010 to that in 2013?
Give a very brief answer. 0.98. What is the ratio of the Pupil-teacher ratio(headcount basis) of World in 2010 to that in 2013?
Ensure brevity in your answer.  0.98. What is the ratio of the Pupil-teacher ratio(headcount basis) in Germany in 2010 to that in 2013?
Ensure brevity in your answer.  1.03. What is the ratio of the Pupil-teacher ratio(headcount basis) in Kyrgyz Republic in 2010 to that in 2013?
Provide a short and direct response. 1.03. What is the difference between the highest and the second highest Pupil-teacher ratio(headcount basis) in High income?
Provide a short and direct response. 0.06. What is the difference between the highest and the second highest Pupil-teacher ratio(headcount basis) of World?
Provide a succinct answer. 0.32. What is the difference between the highest and the second highest Pupil-teacher ratio(headcount basis) in Germany?
Your response must be concise. 0.32. What is the difference between the highest and the second highest Pupil-teacher ratio(headcount basis) in Kyrgyz Republic?
Provide a short and direct response. 0.45. What is the difference between the highest and the lowest Pupil-teacher ratio(headcount basis) of High income?
Provide a short and direct response. 0.28. What is the difference between the highest and the lowest Pupil-teacher ratio(headcount basis) of World?
Your answer should be very brief. 0.77. What is the difference between the highest and the lowest Pupil-teacher ratio(headcount basis) in Germany?
Offer a very short reply. 1.22. What is the difference between the highest and the lowest Pupil-teacher ratio(headcount basis) of Kyrgyz Republic?
Your answer should be compact. 2.03. 